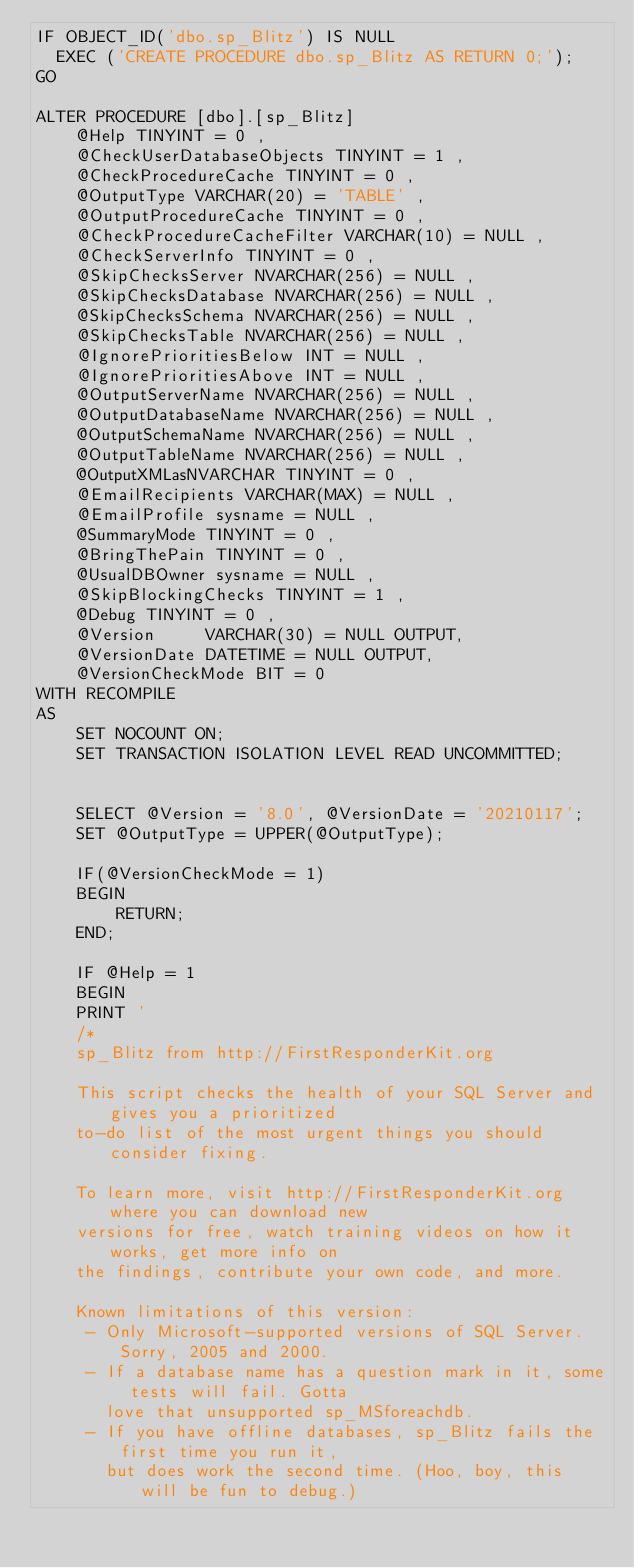Convert code to text. <code><loc_0><loc_0><loc_500><loc_500><_SQL_>IF OBJECT_ID('dbo.sp_Blitz') IS NULL
  EXEC ('CREATE PROCEDURE dbo.sp_Blitz AS RETURN 0;');
GO

ALTER PROCEDURE [dbo].[sp_Blitz]
    @Help TINYINT = 0 ,
    @CheckUserDatabaseObjects TINYINT = 1 ,
    @CheckProcedureCache TINYINT = 0 ,
    @OutputType VARCHAR(20) = 'TABLE' ,
    @OutputProcedureCache TINYINT = 0 ,
    @CheckProcedureCacheFilter VARCHAR(10) = NULL ,
    @CheckServerInfo TINYINT = 0 ,
    @SkipChecksServer NVARCHAR(256) = NULL ,
    @SkipChecksDatabase NVARCHAR(256) = NULL ,
    @SkipChecksSchema NVARCHAR(256) = NULL ,
    @SkipChecksTable NVARCHAR(256) = NULL ,
    @IgnorePrioritiesBelow INT = NULL ,
    @IgnorePrioritiesAbove INT = NULL ,
    @OutputServerName NVARCHAR(256) = NULL ,
    @OutputDatabaseName NVARCHAR(256) = NULL ,
    @OutputSchemaName NVARCHAR(256) = NULL ,
    @OutputTableName NVARCHAR(256) = NULL ,
    @OutputXMLasNVARCHAR TINYINT = 0 ,
    @EmailRecipients VARCHAR(MAX) = NULL ,
    @EmailProfile sysname = NULL ,
    @SummaryMode TINYINT = 0 ,
    @BringThePain TINYINT = 0 ,
    @UsualDBOwner sysname = NULL ,
	@SkipBlockingChecks TINYINT = 1 ,
    @Debug TINYINT = 0 ,
    @Version     VARCHAR(30) = NULL OUTPUT,
	@VersionDate DATETIME = NULL OUTPUT,
    @VersionCheckMode BIT = 0
WITH RECOMPILE
AS
    SET NOCOUNT ON;
	SET TRANSACTION ISOLATION LEVEL READ UNCOMMITTED;
	

	SELECT @Version = '8.0', @VersionDate = '20210117';
	SET @OutputType = UPPER(@OutputType);

    IF(@VersionCheckMode = 1)
	BEGIN
		RETURN;
	END;

	IF @Help = 1 
	BEGIN
	PRINT '
	/*
	sp_Blitz from http://FirstResponderKit.org
	
	This script checks the health of your SQL Server and gives you a prioritized
	to-do list of the most urgent things you should consider fixing.

	To learn more, visit http://FirstResponderKit.org where you can download new
	versions for free, watch training videos on how it works, get more info on
	the findings, contribute your own code, and more.

	Known limitations of this version:
	 - Only Microsoft-supported versions of SQL Server. Sorry, 2005 and 2000.
	 - If a database name has a question mark in it, some tests will fail. Gotta
	   love that unsupported sp_MSforeachdb.
	 - If you have offline databases, sp_Blitz fails the first time you run it,
	   but does work the second time. (Hoo, boy, this will be fun to debug.)</code> 